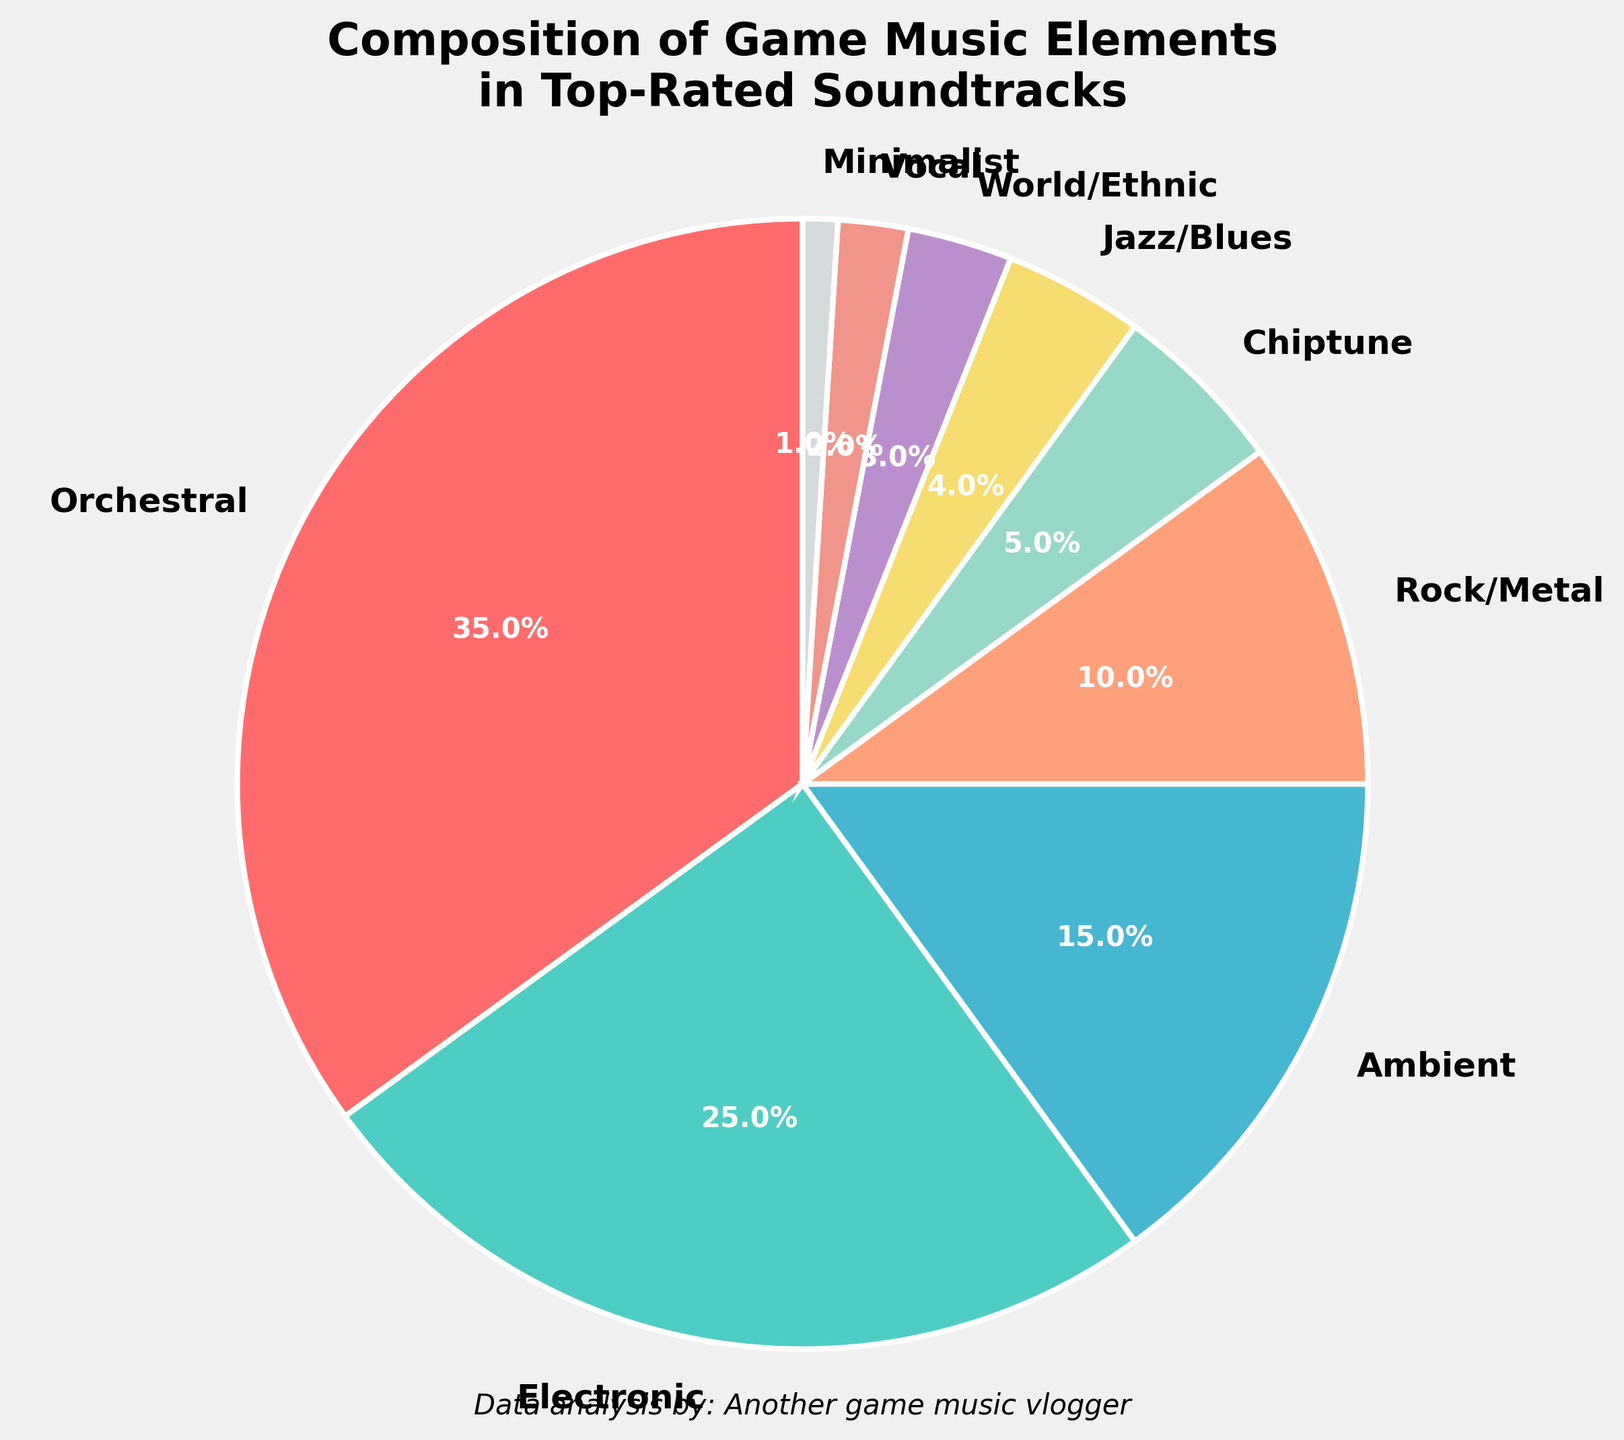What's the total percentage of the top three music elements combined? To find the total percentage of the top three music elements, add the percentages of Orchestral (35%), Electronic (25%), and Ambient (15%). The sum is 35% + 25% + 15% = 75%.
Answer: 75% Which music element has nearly a tenth of the composition in top-rated soundtracks? From the pie chart, Rock/Metal has a 10% share, which is close to a tenth of the composition.
Answer: Rock/Metal What is the difference in percentage between the Electronic and Jazz/Blues elements? The percentage for Electronic is 25%, and for Jazz/Blues, it is 4%. The difference between them is 25% - 4% = 21%.
Answer: 21% Does Ambient music have a larger or smaller share than Chiptune? Ambient music has a 15% share, while Chiptune has a 5% share. Since 15% is greater than 5%, Ambient has a larger share than Chiptune.
Answer: Larger Which part of the pie chart is colored the most brightly, and what percentage does it represent? Orchestral music is colored the brightest (assuming a bright red #FF6B6B) and represents 35% of the composition.
Answer: Orchestral, 35% By what factor is Orchestral music more prevalent than World/Ethnic music? The Orchestral music composition is 35%, while the World/Ethnic music composition is 3%. 35% divided by 3% equals approximately 11.67.
Answer: ~11.67 What’s the combined percentage of the least represented four music elements in the pie chart? Add the percentages of Vocal (2%), Minimalist (1%), World/Ethnic (3%), and Jazz/Blues (4%). The sum is 2% + 1% + 3% + 4% = 10%.
Answer: 10% Which music elements together make up less than a third of the composition? The elements with percentages less than 10% are Chiptune, Jazz/Blues, World/Ethnic, Vocal, and Minimalist. Adding their percentages gives 5% + 4% + 3% + 2% + 1% = 15%, which is less than a third (33.3%).
Answer: Chiptune, Jazz/Blues, World/Ethnic, Vocal, Minimalist 